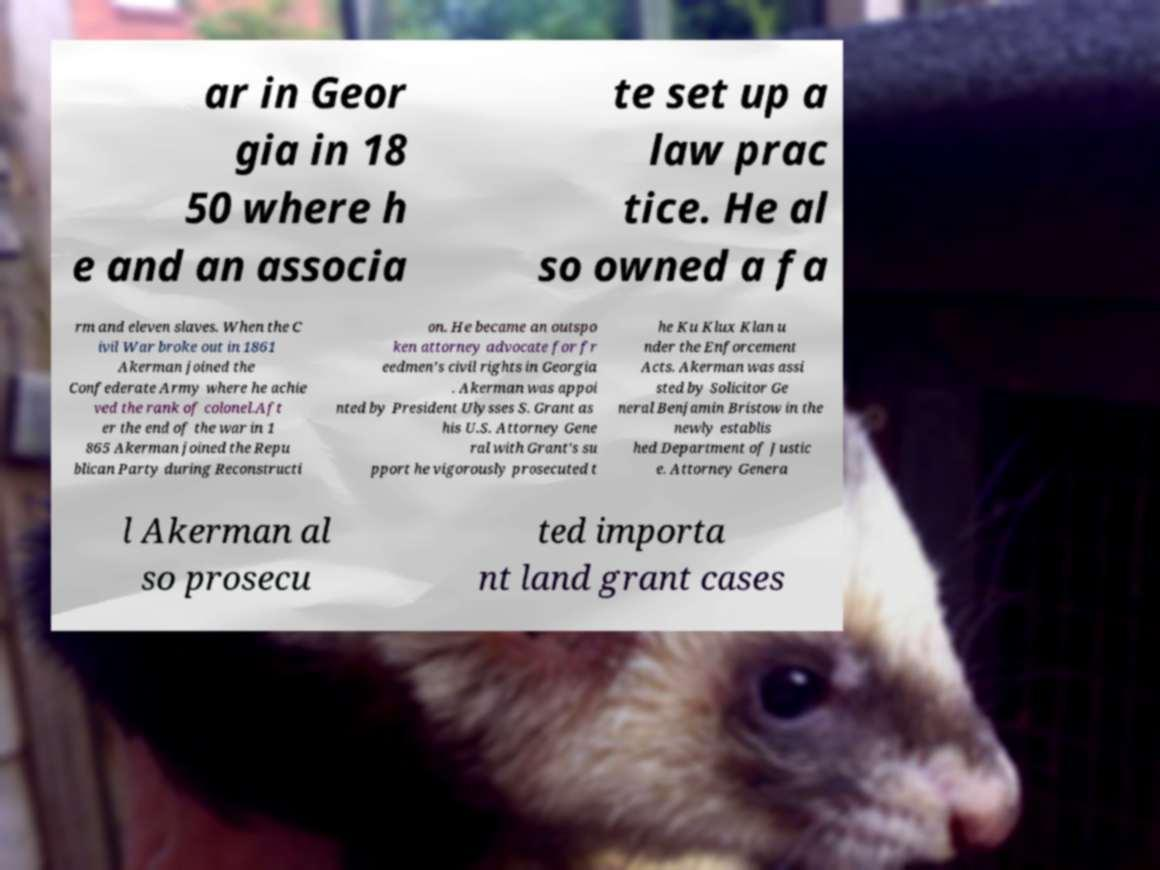Can you read and provide the text displayed in the image?This photo seems to have some interesting text. Can you extract and type it out for me? ar in Geor gia in 18 50 where h e and an associa te set up a law prac tice. He al so owned a fa rm and eleven slaves. When the C ivil War broke out in 1861 Akerman joined the Confederate Army where he achie ved the rank of colonel.Aft er the end of the war in 1 865 Akerman joined the Repu blican Party during Reconstructi on. He became an outspo ken attorney advocate for fr eedmen's civil rights in Georgia . Akerman was appoi nted by President Ulysses S. Grant as his U.S. Attorney Gene ral with Grant's su pport he vigorously prosecuted t he Ku Klux Klan u nder the Enforcement Acts. Akerman was assi sted by Solicitor Ge neral Benjamin Bristow in the newly establis hed Department of Justic e. Attorney Genera l Akerman al so prosecu ted importa nt land grant cases 